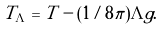Convert formula to latex. <formula><loc_0><loc_0><loc_500><loc_500>T _ { \Lambda } = T - ( 1 / 8 \pi ) \Lambda g .</formula> 